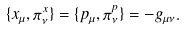<formula> <loc_0><loc_0><loc_500><loc_500>\{ x _ { \mu } , \pi ^ { x } _ { \nu } \} = \{ p _ { \mu } , \pi ^ { p } _ { \nu } \} = - g _ { \mu \nu } .</formula> 